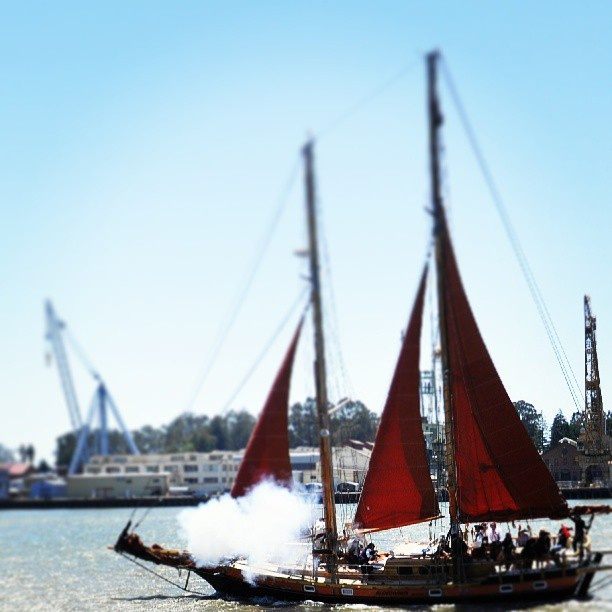Describe the objects in this image and their specific colors. I can see boat in lightblue, white, black, maroon, and gray tones, people in lightblue, black, gray, and tan tones, people in lightblue, black, gray, and darkgray tones, people in lightblue, black, purple, darkgray, and lavender tones, and people in lightblue, black, gray, and lightgray tones in this image. 